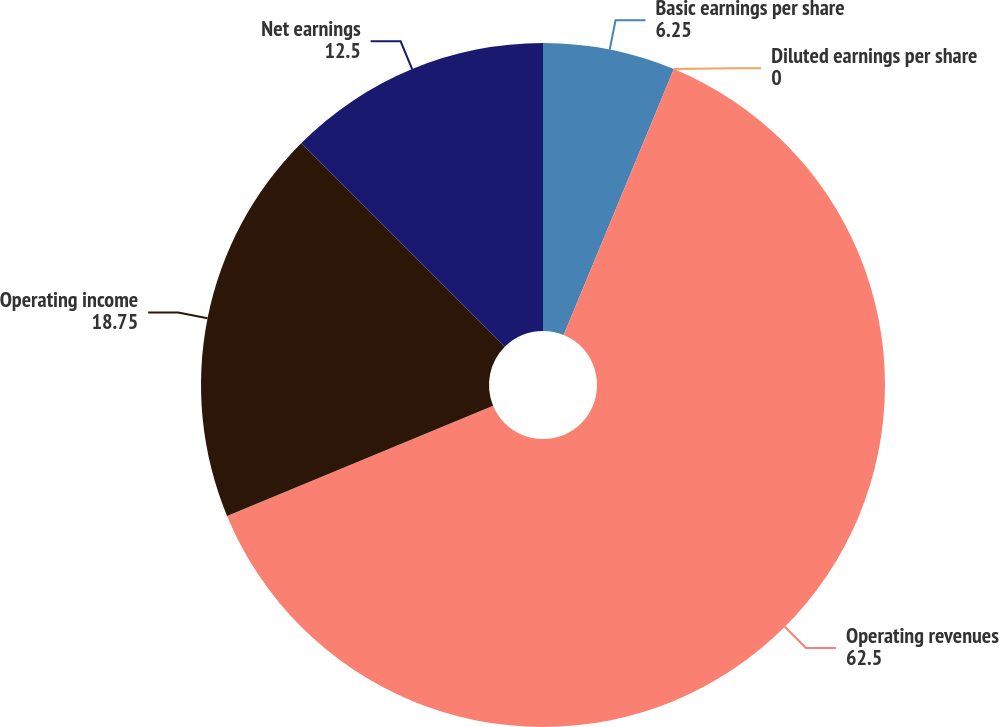Convert chart. <chart><loc_0><loc_0><loc_500><loc_500><pie_chart><fcel>Basic earnings per share<fcel>Diluted earnings per share<fcel>Operating revenues<fcel>Operating income<fcel>Net earnings<nl><fcel>6.25%<fcel>0.0%<fcel>62.5%<fcel>18.75%<fcel>12.5%<nl></chart> 